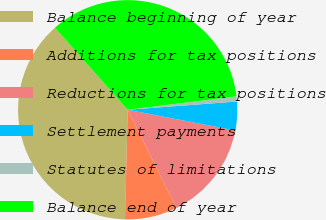Convert chart to OTSL. <chart><loc_0><loc_0><loc_500><loc_500><pie_chart><fcel>Balance beginning of year<fcel>Additions for tax positions<fcel>Reductions for tax positions<fcel>Settlement payments<fcel>Statutes of limitations<fcel>Balance end of year<nl><fcel>38.06%<fcel>7.71%<fcel>14.65%<fcel>4.23%<fcel>0.76%<fcel>34.59%<nl></chart> 